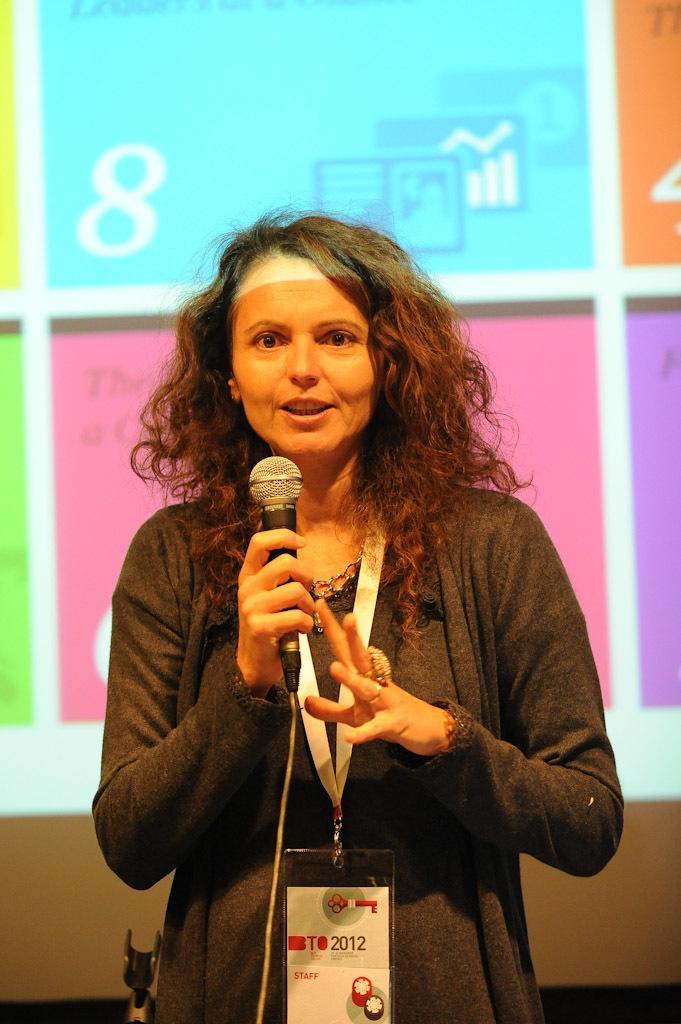Could you give a brief overview of what you see in this image? In the image in the center we can see one lady is standing and she is holding microphone. And back of her we can see screen. 